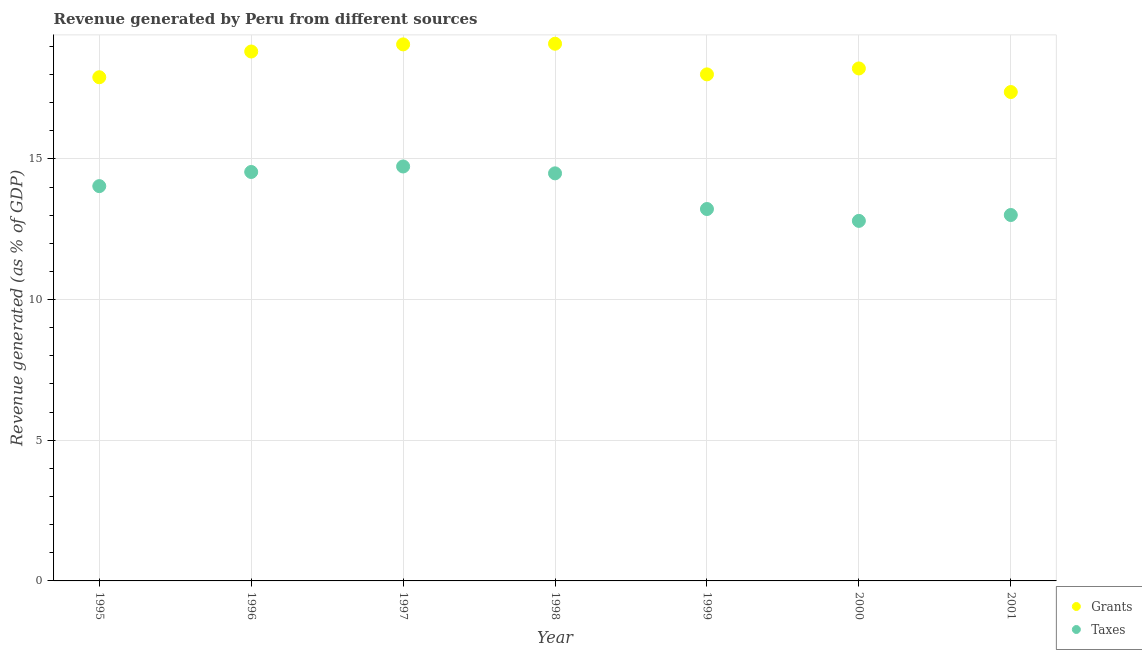Is the number of dotlines equal to the number of legend labels?
Your answer should be compact. Yes. What is the revenue generated by taxes in 1998?
Provide a succinct answer. 14.49. Across all years, what is the maximum revenue generated by taxes?
Your answer should be compact. 14.73. Across all years, what is the minimum revenue generated by grants?
Offer a very short reply. 17.38. In which year was the revenue generated by grants minimum?
Provide a short and direct response. 2001. What is the total revenue generated by taxes in the graph?
Provide a short and direct response. 96.81. What is the difference between the revenue generated by grants in 1996 and that in 2000?
Provide a short and direct response. 0.6. What is the difference between the revenue generated by taxes in 1997 and the revenue generated by grants in 1999?
Make the answer very short. -3.27. What is the average revenue generated by taxes per year?
Offer a terse response. 13.83. In the year 1997, what is the difference between the revenue generated by taxes and revenue generated by grants?
Your response must be concise. -4.34. What is the ratio of the revenue generated by taxes in 1995 to that in 2000?
Give a very brief answer. 1.1. Is the difference between the revenue generated by taxes in 1995 and 2001 greater than the difference between the revenue generated by grants in 1995 and 2001?
Make the answer very short. Yes. What is the difference between the highest and the second highest revenue generated by grants?
Keep it short and to the point. 0.02. What is the difference between the highest and the lowest revenue generated by grants?
Ensure brevity in your answer.  1.72. Is the sum of the revenue generated by grants in 1995 and 1998 greater than the maximum revenue generated by taxes across all years?
Offer a terse response. Yes. Is the revenue generated by taxes strictly less than the revenue generated by grants over the years?
Make the answer very short. Yes. How many years are there in the graph?
Offer a very short reply. 7. Does the graph contain any zero values?
Your answer should be compact. No. Does the graph contain grids?
Your answer should be compact. Yes. Where does the legend appear in the graph?
Give a very brief answer. Bottom right. How many legend labels are there?
Give a very brief answer. 2. How are the legend labels stacked?
Your answer should be very brief. Vertical. What is the title of the graph?
Provide a succinct answer. Revenue generated by Peru from different sources. Does "International Tourists" appear as one of the legend labels in the graph?
Offer a terse response. No. What is the label or title of the Y-axis?
Offer a terse response. Revenue generated (as % of GDP). What is the Revenue generated (as % of GDP) in Grants in 1995?
Make the answer very short. 17.9. What is the Revenue generated (as % of GDP) in Taxes in 1995?
Keep it short and to the point. 14.03. What is the Revenue generated (as % of GDP) of Grants in 1996?
Offer a terse response. 18.82. What is the Revenue generated (as % of GDP) of Taxes in 1996?
Keep it short and to the point. 14.54. What is the Revenue generated (as % of GDP) of Grants in 1997?
Ensure brevity in your answer.  19.07. What is the Revenue generated (as % of GDP) in Taxes in 1997?
Provide a short and direct response. 14.73. What is the Revenue generated (as % of GDP) of Grants in 1998?
Your answer should be very brief. 19.09. What is the Revenue generated (as % of GDP) of Taxes in 1998?
Your response must be concise. 14.49. What is the Revenue generated (as % of GDP) of Grants in 1999?
Provide a short and direct response. 18.01. What is the Revenue generated (as % of GDP) in Taxes in 1999?
Provide a succinct answer. 13.22. What is the Revenue generated (as % of GDP) of Grants in 2000?
Your response must be concise. 18.22. What is the Revenue generated (as % of GDP) of Taxes in 2000?
Your answer should be very brief. 12.8. What is the Revenue generated (as % of GDP) in Grants in 2001?
Your answer should be very brief. 17.38. What is the Revenue generated (as % of GDP) of Taxes in 2001?
Your answer should be very brief. 13.01. Across all years, what is the maximum Revenue generated (as % of GDP) in Grants?
Give a very brief answer. 19.09. Across all years, what is the maximum Revenue generated (as % of GDP) of Taxes?
Offer a very short reply. 14.73. Across all years, what is the minimum Revenue generated (as % of GDP) in Grants?
Provide a succinct answer. 17.38. Across all years, what is the minimum Revenue generated (as % of GDP) in Taxes?
Your answer should be very brief. 12.8. What is the total Revenue generated (as % of GDP) of Grants in the graph?
Make the answer very short. 128.48. What is the total Revenue generated (as % of GDP) in Taxes in the graph?
Offer a terse response. 96.81. What is the difference between the Revenue generated (as % of GDP) of Grants in 1995 and that in 1996?
Provide a succinct answer. -0.92. What is the difference between the Revenue generated (as % of GDP) of Taxes in 1995 and that in 1996?
Offer a very short reply. -0.5. What is the difference between the Revenue generated (as % of GDP) in Grants in 1995 and that in 1997?
Provide a short and direct response. -1.17. What is the difference between the Revenue generated (as % of GDP) of Taxes in 1995 and that in 1997?
Ensure brevity in your answer.  -0.7. What is the difference between the Revenue generated (as % of GDP) of Grants in 1995 and that in 1998?
Give a very brief answer. -1.19. What is the difference between the Revenue generated (as % of GDP) in Taxes in 1995 and that in 1998?
Offer a terse response. -0.45. What is the difference between the Revenue generated (as % of GDP) in Grants in 1995 and that in 1999?
Your answer should be very brief. -0.1. What is the difference between the Revenue generated (as % of GDP) of Taxes in 1995 and that in 1999?
Your answer should be very brief. 0.81. What is the difference between the Revenue generated (as % of GDP) of Grants in 1995 and that in 2000?
Make the answer very short. -0.31. What is the difference between the Revenue generated (as % of GDP) in Taxes in 1995 and that in 2000?
Your answer should be compact. 1.24. What is the difference between the Revenue generated (as % of GDP) of Grants in 1995 and that in 2001?
Your answer should be compact. 0.53. What is the difference between the Revenue generated (as % of GDP) in Taxes in 1995 and that in 2001?
Offer a terse response. 1.03. What is the difference between the Revenue generated (as % of GDP) in Grants in 1996 and that in 1997?
Your answer should be compact. -0.25. What is the difference between the Revenue generated (as % of GDP) in Taxes in 1996 and that in 1997?
Provide a succinct answer. -0.2. What is the difference between the Revenue generated (as % of GDP) of Grants in 1996 and that in 1998?
Ensure brevity in your answer.  -0.28. What is the difference between the Revenue generated (as % of GDP) of Taxes in 1996 and that in 1998?
Your answer should be compact. 0.05. What is the difference between the Revenue generated (as % of GDP) in Grants in 1996 and that in 1999?
Make the answer very short. 0.81. What is the difference between the Revenue generated (as % of GDP) of Taxes in 1996 and that in 1999?
Offer a very short reply. 1.32. What is the difference between the Revenue generated (as % of GDP) of Grants in 1996 and that in 2000?
Offer a terse response. 0.6. What is the difference between the Revenue generated (as % of GDP) of Taxes in 1996 and that in 2000?
Your response must be concise. 1.74. What is the difference between the Revenue generated (as % of GDP) in Grants in 1996 and that in 2001?
Your answer should be very brief. 1.44. What is the difference between the Revenue generated (as % of GDP) in Taxes in 1996 and that in 2001?
Your answer should be compact. 1.53. What is the difference between the Revenue generated (as % of GDP) in Grants in 1997 and that in 1998?
Provide a short and direct response. -0.02. What is the difference between the Revenue generated (as % of GDP) in Taxes in 1997 and that in 1998?
Offer a terse response. 0.24. What is the difference between the Revenue generated (as % of GDP) of Grants in 1997 and that in 1999?
Ensure brevity in your answer.  1.07. What is the difference between the Revenue generated (as % of GDP) in Taxes in 1997 and that in 1999?
Ensure brevity in your answer.  1.51. What is the difference between the Revenue generated (as % of GDP) in Grants in 1997 and that in 2000?
Your answer should be compact. 0.85. What is the difference between the Revenue generated (as % of GDP) in Taxes in 1997 and that in 2000?
Your answer should be very brief. 1.93. What is the difference between the Revenue generated (as % of GDP) of Grants in 1997 and that in 2001?
Make the answer very short. 1.69. What is the difference between the Revenue generated (as % of GDP) in Taxes in 1997 and that in 2001?
Ensure brevity in your answer.  1.73. What is the difference between the Revenue generated (as % of GDP) of Grants in 1998 and that in 1999?
Offer a terse response. 1.09. What is the difference between the Revenue generated (as % of GDP) of Taxes in 1998 and that in 1999?
Give a very brief answer. 1.27. What is the difference between the Revenue generated (as % of GDP) in Grants in 1998 and that in 2000?
Offer a very short reply. 0.88. What is the difference between the Revenue generated (as % of GDP) of Taxes in 1998 and that in 2000?
Provide a succinct answer. 1.69. What is the difference between the Revenue generated (as % of GDP) of Grants in 1998 and that in 2001?
Your answer should be compact. 1.72. What is the difference between the Revenue generated (as % of GDP) in Taxes in 1998 and that in 2001?
Ensure brevity in your answer.  1.48. What is the difference between the Revenue generated (as % of GDP) of Grants in 1999 and that in 2000?
Offer a terse response. -0.21. What is the difference between the Revenue generated (as % of GDP) in Taxes in 1999 and that in 2000?
Give a very brief answer. 0.42. What is the difference between the Revenue generated (as % of GDP) in Grants in 1999 and that in 2001?
Offer a very short reply. 0.63. What is the difference between the Revenue generated (as % of GDP) of Taxes in 1999 and that in 2001?
Give a very brief answer. 0.21. What is the difference between the Revenue generated (as % of GDP) in Grants in 2000 and that in 2001?
Offer a very short reply. 0.84. What is the difference between the Revenue generated (as % of GDP) in Taxes in 2000 and that in 2001?
Make the answer very short. -0.21. What is the difference between the Revenue generated (as % of GDP) of Grants in 1995 and the Revenue generated (as % of GDP) of Taxes in 1996?
Ensure brevity in your answer.  3.37. What is the difference between the Revenue generated (as % of GDP) of Grants in 1995 and the Revenue generated (as % of GDP) of Taxes in 1997?
Make the answer very short. 3.17. What is the difference between the Revenue generated (as % of GDP) of Grants in 1995 and the Revenue generated (as % of GDP) of Taxes in 1998?
Your response must be concise. 3.42. What is the difference between the Revenue generated (as % of GDP) in Grants in 1995 and the Revenue generated (as % of GDP) in Taxes in 1999?
Your answer should be compact. 4.68. What is the difference between the Revenue generated (as % of GDP) of Grants in 1995 and the Revenue generated (as % of GDP) of Taxes in 2000?
Provide a short and direct response. 5.11. What is the difference between the Revenue generated (as % of GDP) of Grants in 1995 and the Revenue generated (as % of GDP) of Taxes in 2001?
Your response must be concise. 4.9. What is the difference between the Revenue generated (as % of GDP) of Grants in 1996 and the Revenue generated (as % of GDP) of Taxes in 1997?
Give a very brief answer. 4.09. What is the difference between the Revenue generated (as % of GDP) in Grants in 1996 and the Revenue generated (as % of GDP) in Taxes in 1998?
Provide a succinct answer. 4.33. What is the difference between the Revenue generated (as % of GDP) of Grants in 1996 and the Revenue generated (as % of GDP) of Taxes in 1999?
Offer a terse response. 5.6. What is the difference between the Revenue generated (as % of GDP) in Grants in 1996 and the Revenue generated (as % of GDP) in Taxes in 2000?
Provide a short and direct response. 6.02. What is the difference between the Revenue generated (as % of GDP) in Grants in 1996 and the Revenue generated (as % of GDP) in Taxes in 2001?
Offer a terse response. 5.81. What is the difference between the Revenue generated (as % of GDP) of Grants in 1997 and the Revenue generated (as % of GDP) of Taxes in 1998?
Keep it short and to the point. 4.58. What is the difference between the Revenue generated (as % of GDP) of Grants in 1997 and the Revenue generated (as % of GDP) of Taxes in 1999?
Offer a very short reply. 5.85. What is the difference between the Revenue generated (as % of GDP) in Grants in 1997 and the Revenue generated (as % of GDP) in Taxes in 2000?
Your answer should be compact. 6.27. What is the difference between the Revenue generated (as % of GDP) in Grants in 1997 and the Revenue generated (as % of GDP) in Taxes in 2001?
Your answer should be very brief. 6.06. What is the difference between the Revenue generated (as % of GDP) of Grants in 1998 and the Revenue generated (as % of GDP) of Taxes in 1999?
Ensure brevity in your answer.  5.88. What is the difference between the Revenue generated (as % of GDP) of Grants in 1998 and the Revenue generated (as % of GDP) of Taxes in 2000?
Keep it short and to the point. 6.3. What is the difference between the Revenue generated (as % of GDP) of Grants in 1998 and the Revenue generated (as % of GDP) of Taxes in 2001?
Give a very brief answer. 6.09. What is the difference between the Revenue generated (as % of GDP) of Grants in 1999 and the Revenue generated (as % of GDP) of Taxes in 2000?
Your answer should be compact. 5.21. What is the difference between the Revenue generated (as % of GDP) of Grants in 1999 and the Revenue generated (as % of GDP) of Taxes in 2001?
Your response must be concise. 5. What is the difference between the Revenue generated (as % of GDP) of Grants in 2000 and the Revenue generated (as % of GDP) of Taxes in 2001?
Ensure brevity in your answer.  5.21. What is the average Revenue generated (as % of GDP) in Grants per year?
Offer a terse response. 18.35. What is the average Revenue generated (as % of GDP) in Taxes per year?
Keep it short and to the point. 13.83. In the year 1995, what is the difference between the Revenue generated (as % of GDP) of Grants and Revenue generated (as % of GDP) of Taxes?
Give a very brief answer. 3.87. In the year 1996, what is the difference between the Revenue generated (as % of GDP) of Grants and Revenue generated (as % of GDP) of Taxes?
Make the answer very short. 4.28. In the year 1997, what is the difference between the Revenue generated (as % of GDP) in Grants and Revenue generated (as % of GDP) in Taxes?
Offer a terse response. 4.34. In the year 1998, what is the difference between the Revenue generated (as % of GDP) in Grants and Revenue generated (as % of GDP) in Taxes?
Give a very brief answer. 4.61. In the year 1999, what is the difference between the Revenue generated (as % of GDP) of Grants and Revenue generated (as % of GDP) of Taxes?
Make the answer very short. 4.79. In the year 2000, what is the difference between the Revenue generated (as % of GDP) of Grants and Revenue generated (as % of GDP) of Taxes?
Provide a short and direct response. 5.42. In the year 2001, what is the difference between the Revenue generated (as % of GDP) in Grants and Revenue generated (as % of GDP) in Taxes?
Your answer should be very brief. 4.37. What is the ratio of the Revenue generated (as % of GDP) in Grants in 1995 to that in 1996?
Make the answer very short. 0.95. What is the ratio of the Revenue generated (as % of GDP) of Taxes in 1995 to that in 1996?
Your response must be concise. 0.97. What is the ratio of the Revenue generated (as % of GDP) in Grants in 1995 to that in 1997?
Provide a succinct answer. 0.94. What is the ratio of the Revenue generated (as % of GDP) of Taxes in 1995 to that in 1997?
Your response must be concise. 0.95. What is the ratio of the Revenue generated (as % of GDP) in Grants in 1995 to that in 1998?
Give a very brief answer. 0.94. What is the ratio of the Revenue generated (as % of GDP) of Taxes in 1995 to that in 1998?
Your answer should be compact. 0.97. What is the ratio of the Revenue generated (as % of GDP) in Taxes in 1995 to that in 1999?
Provide a succinct answer. 1.06. What is the ratio of the Revenue generated (as % of GDP) of Grants in 1995 to that in 2000?
Make the answer very short. 0.98. What is the ratio of the Revenue generated (as % of GDP) in Taxes in 1995 to that in 2000?
Offer a very short reply. 1.1. What is the ratio of the Revenue generated (as % of GDP) in Grants in 1995 to that in 2001?
Provide a short and direct response. 1.03. What is the ratio of the Revenue generated (as % of GDP) of Taxes in 1995 to that in 2001?
Your response must be concise. 1.08. What is the ratio of the Revenue generated (as % of GDP) of Grants in 1996 to that in 1997?
Ensure brevity in your answer.  0.99. What is the ratio of the Revenue generated (as % of GDP) of Taxes in 1996 to that in 1997?
Keep it short and to the point. 0.99. What is the ratio of the Revenue generated (as % of GDP) in Grants in 1996 to that in 1998?
Your response must be concise. 0.99. What is the ratio of the Revenue generated (as % of GDP) of Grants in 1996 to that in 1999?
Keep it short and to the point. 1.05. What is the ratio of the Revenue generated (as % of GDP) in Taxes in 1996 to that in 1999?
Provide a succinct answer. 1.1. What is the ratio of the Revenue generated (as % of GDP) in Grants in 1996 to that in 2000?
Offer a very short reply. 1.03. What is the ratio of the Revenue generated (as % of GDP) of Taxes in 1996 to that in 2000?
Keep it short and to the point. 1.14. What is the ratio of the Revenue generated (as % of GDP) in Grants in 1996 to that in 2001?
Provide a succinct answer. 1.08. What is the ratio of the Revenue generated (as % of GDP) in Taxes in 1996 to that in 2001?
Ensure brevity in your answer.  1.12. What is the ratio of the Revenue generated (as % of GDP) of Taxes in 1997 to that in 1998?
Offer a very short reply. 1.02. What is the ratio of the Revenue generated (as % of GDP) in Grants in 1997 to that in 1999?
Give a very brief answer. 1.06. What is the ratio of the Revenue generated (as % of GDP) of Taxes in 1997 to that in 1999?
Make the answer very short. 1.11. What is the ratio of the Revenue generated (as % of GDP) in Grants in 1997 to that in 2000?
Offer a very short reply. 1.05. What is the ratio of the Revenue generated (as % of GDP) in Taxes in 1997 to that in 2000?
Keep it short and to the point. 1.15. What is the ratio of the Revenue generated (as % of GDP) of Grants in 1997 to that in 2001?
Your answer should be very brief. 1.1. What is the ratio of the Revenue generated (as % of GDP) in Taxes in 1997 to that in 2001?
Keep it short and to the point. 1.13. What is the ratio of the Revenue generated (as % of GDP) in Grants in 1998 to that in 1999?
Your answer should be compact. 1.06. What is the ratio of the Revenue generated (as % of GDP) in Taxes in 1998 to that in 1999?
Offer a very short reply. 1.1. What is the ratio of the Revenue generated (as % of GDP) in Grants in 1998 to that in 2000?
Keep it short and to the point. 1.05. What is the ratio of the Revenue generated (as % of GDP) of Taxes in 1998 to that in 2000?
Make the answer very short. 1.13. What is the ratio of the Revenue generated (as % of GDP) of Grants in 1998 to that in 2001?
Provide a short and direct response. 1.1. What is the ratio of the Revenue generated (as % of GDP) in Taxes in 1998 to that in 2001?
Ensure brevity in your answer.  1.11. What is the ratio of the Revenue generated (as % of GDP) of Grants in 1999 to that in 2000?
Make the answer very short. 0.99. What is the ratio of the Revenue generated (as % of GDP) in Taxes in 1999 to that in 2000?
Offer a very short reply. 1.03. What is the ratio of the Revenue generated (as % of GDP) of Grants in 1999 to that in 2001?
Your response must be concise. 1.04. What is the ratio of the Revenue generated (as % of GDP) in Taxes in 1999 to that in 2001?
Your response must be concise. 1.02. What is the ratio of the Revenue generated (as % of GDP) of Grants in 2000 to that in 2001?
Your answer should be very brief. 1.05. What is the ratio of the Revenue generated (as % of GDP) in Taxes in 2000 to that in 2001?
Your response must be concise. 0.98. What is the difference between the highest and the second highest Revenue generated (as % of GDP) of Grants?
Keep it short and to the point. 0.02. What is the difference between the highest and the second highest Revenue generated (as % of GDP) of Taxes?
Offer a very short reply. 0.2. What is the difference between the highest and the lowest Revenue generated (as % of GDP) of Grants?
Offer a terse response. 1.72. What is the difference between the highest and the lowest Revenue generated (as % of GDP) in Taxes?
Provide a short and direct response. 1.93. 